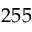Convert formula to latex. <formula><loc_0><loc_0><loc_500><loc_500>2 5 5</formula> 